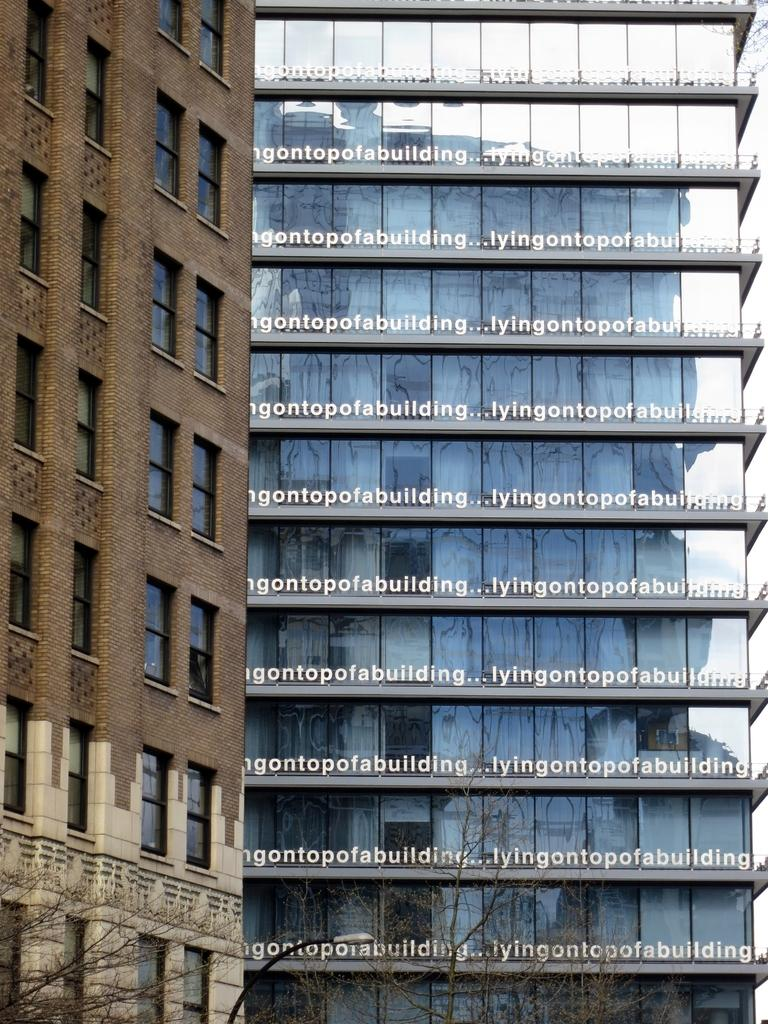What type of structures can be seen in the image? There are buildings in the image. What natural elements are present in the image? There are trees in the image. Can you describe any imperfections or marks on the image itself? There are watermarks on the image. How many dinosaurs can be seen in the image? There are no dinosaurs present in the image. What type of minister is depicted in the image? There is no minister depicted in the image. 